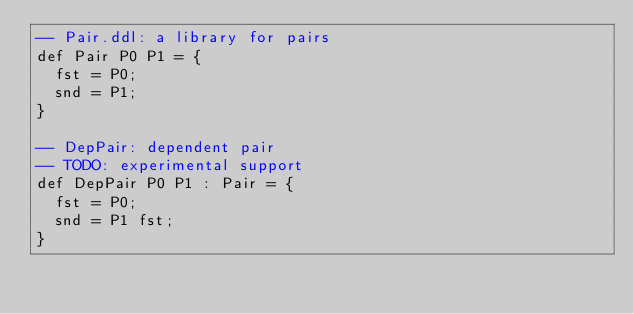Convert code to text. <code><loc_0><loc_0><loc_500><loc_500><_SQL_>-- Pair.ddl: a library for pairs
def Pair P0 P1 = {
  fst = P0;
  snd = P1;
}

-- DepPair: dependent pair
-- TODO: experimental support
def DepPair P0 P1 : Pair = {
  fst = P0;
  snd = P1 fst;
}
</code> 